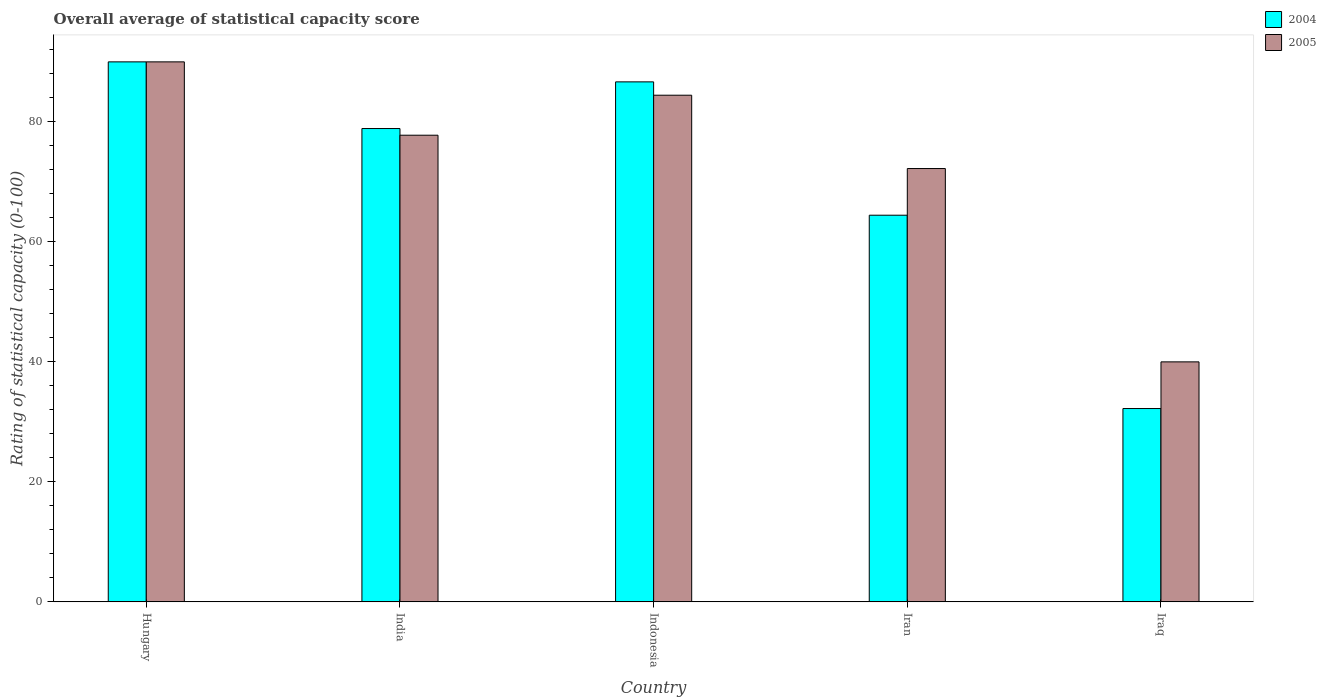Are the number of bars on each tick of the X-axis equal?
Offer a very short reply. Yes. How many bars are there on the 5th tick from the right?
Provide a short and direct response. 2. In how many cases, is the number of bars for a given country not equal to the number of legend labels?
Make the answer very short. 0. Across all countries, what is the minimum rating of statistical capacity in 2004?
Offer a very short reply. 32.22. In which country was the rating of statistical capacity in 2004 maximum?
Your response must be concise. Hungary. In which country was the rating of statistical capacity in 2005 minimum?
Your answer should be very brief. Iraq. What is the total rating of statistical capacity in 2005 in the graph?
Give a very brief answer. 364.44. What is the difference between the rating of statistical capacity in 2004 in Hungary and that in Iraq?
Offer a very short reply. 57.78. What is the difference between the rating of statistical capacity in 2004 in Iraq and the rating of statistical capacity in 2005 in Iran?
Your answer should be very brief. -40. What is the average rating of statistical capacity in 2004 per country?
Your answer should be compact. 70.44. What is the difference between the rating of statistical capacity of/in 2005 and rating of statistical capacity of/in 2004 in Iraq?
Keep it short and to the point. 7.78. Is the rating of statistical capacity in 2004 in Iran less than that in Iraq?
Give a very brief answer. No. Is the difference between the rating of statistical capacity in 2005 in India and Iraq greater than the difference between the rating of statistical capacity in 2004 in India and Iraq?
Keep it short and to the point. No. What is the difference between the highest and the second highest rating of statistical capacity in 2005?
Provide a succinct answer. 5.56. In how many countries, is the rating of statistical capacity in 2004 greater than the average rating of statistical capacity in 2004 taken over all countries?
Your answer should be compact. 3. What does the 2nd bar from the left in Hungary represents?
Provide a short and direct response. 2005. How many bars are there?
Make the answer very short. 10. Are all the bars in the graph horizontal?
Provide a succinct answer. No. How many countries are there in the graph?
Offer a terse response. 5. What is the difference between two consecutive major ticks on the Y-axis?
Ensure brevity in your answer.  20. Are the values on the major ticks of Y-axis written in scientific E-notation?
Offer a very short reply. No. What is the title of the graph?
Provide a short and direct response. Overall average of statistical capacity score. What is the label or title of the X-axis?
Ensure brevity in your answer.  Country. What is the label or title of the Y-axis?
Keep it short and to the point. Rating of statistical capacity (0-100). What is the Rating of statistical capacity (0-100) in 2005 in Hungary?
Ensure brevity in your answer.  90. What is the Rating of statistical capacity (0-100) of 2004 in India?
Make the answer very short. 78.89. What is the Rating of statistical capacity (0-100) of 2005 in India?
Your answer should be compact. 77.78. What is the Rating of statistical capacity (0-100) of 2004 in Indonesia?
Provide a succinct answer. 86.67. What is the Rating of statistical capacity (0-100) of 2005 in Indonesia?
Provide a short and direct response. 84.44. What is the Rating of statistical capacity (0-100) of 2004 in Iran?
Keep it short and to the point. 64.44. What is the Rating of statistical capacity (0-100) in 2005 in Iran?
Give a very brief answer. 72.22. What is the Rating of statistical capacity (0-100) of 2004 in Iraq?
Provide a succinct answer. 32.22. Across all countries, what is the maximum Rating of statistical capacity (0-100) of 2005?
Make the answer very short. 90. Across all countries, what is the minimum Rating of statistical capacity (0-100) in 2004?
Offer a terse response. 32.22. Across all countries, what is the minimum Rating of statistical capacity (0-100) of 2005?
Your answer should be very brief. 40. What is the total Rating of statistical capacity (0-100) in 2004 in the graph?
Make the answer very short. 352.22. What is the total Rating of statistical capacity (0-100) of 2005 in the graph?
Provide a short and direct response. 364.44. What is the difference between the Rating of statistical capacity (0-100) in 2004 in Hungary and that in India?
Give a very brief answer. 11.11. What is the difference between the Rating of statistical capacity (0-100) in 2005 in Hungary and that in India?
Your response must be concise. 12.22. What is the difference between the Rating of statistical capacity (0-100) of 2005 in Hungary and that in Indonesia?
Ensure brevity in your answer.  5.56. What is the difference between the Rating of statistical capacity (0-100) of 2004 in Hungary and that in Iran?
Keep it short and to the point. 25.56. What is the difference between the Rating of statistical capacity (0-100) of 2005 in Hungary and that in Iran?
Your answer should be very brief. 17.78. What is the difference between the Rating of statistical capacity (0-100) of 2004 in Hungary and that in Iraq?
Your answer should be very brief. 57.78. What is the difference between the Rating of statistical capacity (0-100) of 2005 in Hungary and that in Iraq?
Your answer should be compact. 50. What is the difference between the Rating of statistical capacity (0-100) of 2004 in India and that in Indonesia?
Provide a short and direct response. -7.78. What is the difference between the Rating of statistical capacity (0-100) in 2005 in India and that in Indonesia?
Ensure brevity in your answer.  -6.67. What is the difference between the Rating of statistical capacity (0-100) of 2004 in India and that in Iran?
Provide a succinct answer. 14.44. What is the difference between the Rating of statistical capacity (0-100) in 2005 in India and that in Iran?
Make the answer very short. 5.56. What is the difference between the Rating of statistical capacity (0-100) in 2004 in India and that in Iraq?
Make the answer very short. 46.67. What is the difference between the Rating of statistical capacity (0-100) of 2005 in India and that in Iraq?
Your answer should be very brief. 37.78. What is the difference between the Rating of statistical capacity (0-100) in 2004 in Indonesia and that in Iran?
Ensure brevity in your answer.  22.22. What is the difference between the Rating of statistical capacity (0-100) of 2005 in Indonesia and that in Iran?
Your answer should be very brief. 12.22. What is the difference between the Rating of statistical capacity (0-100) of 2004 in Indonesia and that in Iraq?
Make the answer very short. 54.44. What is the difference between the Rating of statistical capacity (0-100) in 2005 in Indonesia and that in Iraq?
Offer a very short reply. 44.44. What is the difference between the Rating of statistical capacity (0-100) in 2004 in Iran and that in Iraq?
Provide a short and direct response. 32.22. What is the difference between the Rating of statistical capacity (0-100) of 2005 in Iran and that in Iraq?
Your answer should be very brief. 32.22. What is the difference between the Rating of statistical capacity (0-100) of 2004 in Hungary and the Rating of statistical capacity (0-100) of 2005 in India?
Provide a short and direct response. 12.22. What is the difference between the Rating of statistical capacity (0-100) in 2004 in Hungary and the Rating of statistical capacity (0-100) in 2005 in Indonesia?
Give a very brief answer. 5.56. What is the difference between the Rating of statistical capacity (0-100) of 2004 in Hungary and the Rating of statistical capacity (0-100) of 2005 in Iran?
Provide a short and direct response. 17.78. What is the difference between the Rating of statistical capacity (0-100) in 2004 in Hungary and the Rating of statistical capacity (0-100) in 2005 in Iraq?
Offer a terse response. 50. What is the difference between the Rating of statistical capacity (0-100) in 2004 in India and the Rating of statistical capacity (0-100) in 2005 in Indonesia?
Offer a very short reply. -5.56. What is the difference between the Rating of statistical capacity (0-100) of 2004 in India and the Rating of statistical capacity (0-100) of 2005 in Iran?
Provide a succinct answer. 6.67. What is the difference between the Rating of statistical capacity (0-100) in 2004 in India and the Rating of statistical capacity (0-100) in 2005 in Iraq?
Provide a succinct answer. 38.89. What is the difference between the Rating of statistical capacity (0-100) in 2004 in Indonesia and the Rating of statistical capacity (0-100) in 2005 in Iran?
Offer a very short reply. 14.44. What is the difference between the Rating of statistical capacity (0-100) of 2004 in Indonesia and the Rating of statistical capacity (0-100) of 2005 in Iraq?
Offer a very short reply. 46.67. What is the difference between the Rating of statistical capacity (0-100) in 2004 in Iran and the Rating of statistical capacity (0-100) in 2005 in Iraq?
Ensure brevity in your answer.  24.44. What is the average Rating of statistical capacity (0-100) of 2004 per country?
Ensure brevity in your answer.  70.44. What is the average Rating of statistical capacity (0-100) in 2005 per country?
Offer a terse response. 72.89. What is the difference between the Rating of statistical capacity (0-100) of 2004 and Rating of statistical capacity (0-100) of 2005 in Hungary?
Your answer should be very brief. 0. What is the difference between the Rating of statistical capacity (0-100) in 2004 and Rating of statistical capacity (0-100) in 2005 in India?
Offer a very short reply. 1.11. What is the difference between the Rating of statistical capacity (0-100) in 2004 and Rating of statistical capacity (0-100) in 2005 in Indonesia?
Your answer should be compact. 2.22. What is the difference between the Rating of statistical capacity (0-100) of 2004 and Rating of statistical capacity (0-100) of 2005 in Iran?
Your answer should be compact. -7.78. What is the difference between the Rating of statistical capacity (0-100) of 2004 and Rating of statistical capacity (0-100) of 2005 in Iraq?
Keep it short and to the point. -7.78. What is the ratio of the Rating of statistical capacity (0-100) in 2004 in Hungary to that in India?
Offer a terse response. 1.14. What is the ratio of the Rating of statistical capacity (0-100) in 2005 in Hungary to that in India?
Your answer should be very brief. 1.16. What is the ratio of the Rating of statistical capacity (0-100) of 2004 in Hungary to that in Indonesia?
Your response must be concise. 1.04. What is the ratio of the Rating of statistical capacity (0-100) in 2005 in Hungary to that in Indonesia?
Make the answer very short. 1.07. What is the ratio of the Rating of statistical capacity (0-100) of 2004 in Hungary to that in Iran?
Give a very brief answer. 1.4. What is the ratio of the Rating of statistical capacity (0-100) in 2005 in Hungary to that in Iran?
Your response must be concise. 1.25. What is the ratio of the Rating of statistical capacity (0-100) in 2004 in Hungary to that in Iraq?
Make the answer very short. 2.79. What is the ratio of the Rating of statistical capacity (0-100) in 2005 in Hungary to that in Iraq?
Give a very brief answer. 2.25. What is the ratio of the Rating of statistical capacity (0-100) in 2004 in India to that in Indonesia?
Keep it short and to the point. 0.91. What is the ratio of the Rating of statistical capacity (0-100) of 2005 in India to that in Indonesia?
Your answer should be very brief. 0.92. What is the ratio of the Rating of statistical capacity (0-100) in 2004 in India to that in Iran?
Your answer should be compact. 1.22. What is the ratio of the Rating of statistical capacity (0-100) of 2005 in India to that in Iran?
Provide a succinct answer. 1.08. What is the ratio of the Rating of statistical capacity (0-100) in 2004 in India to that in Iraq?
Keep it short and to the point. 2.45. What is the ratio of the Rating of statistical capacity (0-100) of 2005 in India to that in Iraq?
Your answer should be very brief. 1.94. What is the ratio of the Rating of statistical capacity (0-100) of 2004 in Indonesia to that in Iran?
Provide a succinct answer. 1.34. What is the ratio of the Rating of statistical capacity (0-100) of 2005 in Indonesia to that in Iran?
Your answer should be compact. 1.17. What is the ratio of the Rating of statistical capacity (0-100) of 2004 in Indonesia to that in Iraq?
Your response must be concise. 2.69. What is the ratio of the Rating of statistical capacity (0-100) in 2005 in Indonesia to that in Iraq?
Provide a short and direct response. 2.11. What is the ratio of the Rating of statistical capacity (0-100) in 2005 in Iran to that in Iraq?
Make the answer very short. 1.81. What is the difference between the highest and the second highest Rating of statistical capacity (0-100) in 2004?
Keep it short and to the point. 3.33. What is the difference between the highest and the second highest Rating of statistical capacity (0-100) of 2005?
Make the answer very short. 5.56. What is the difference between the highest and the lowest Rating of statistical capacity (0-100) in 2004?
Keep it short and to the point. 57.78. What is the difference between the highest and the lowest Rating of statistical capacity (0-100) in 2005?
Your answer should be very brief. 50. 